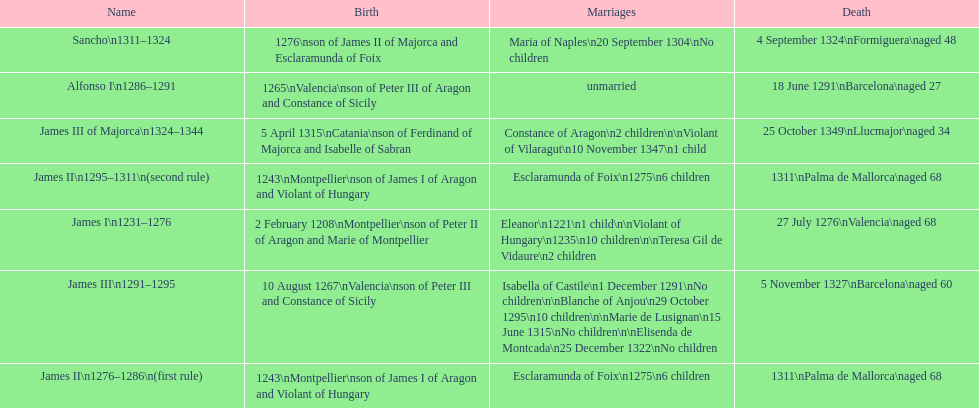What name is above james iii and below james ii? Alfonso I. 